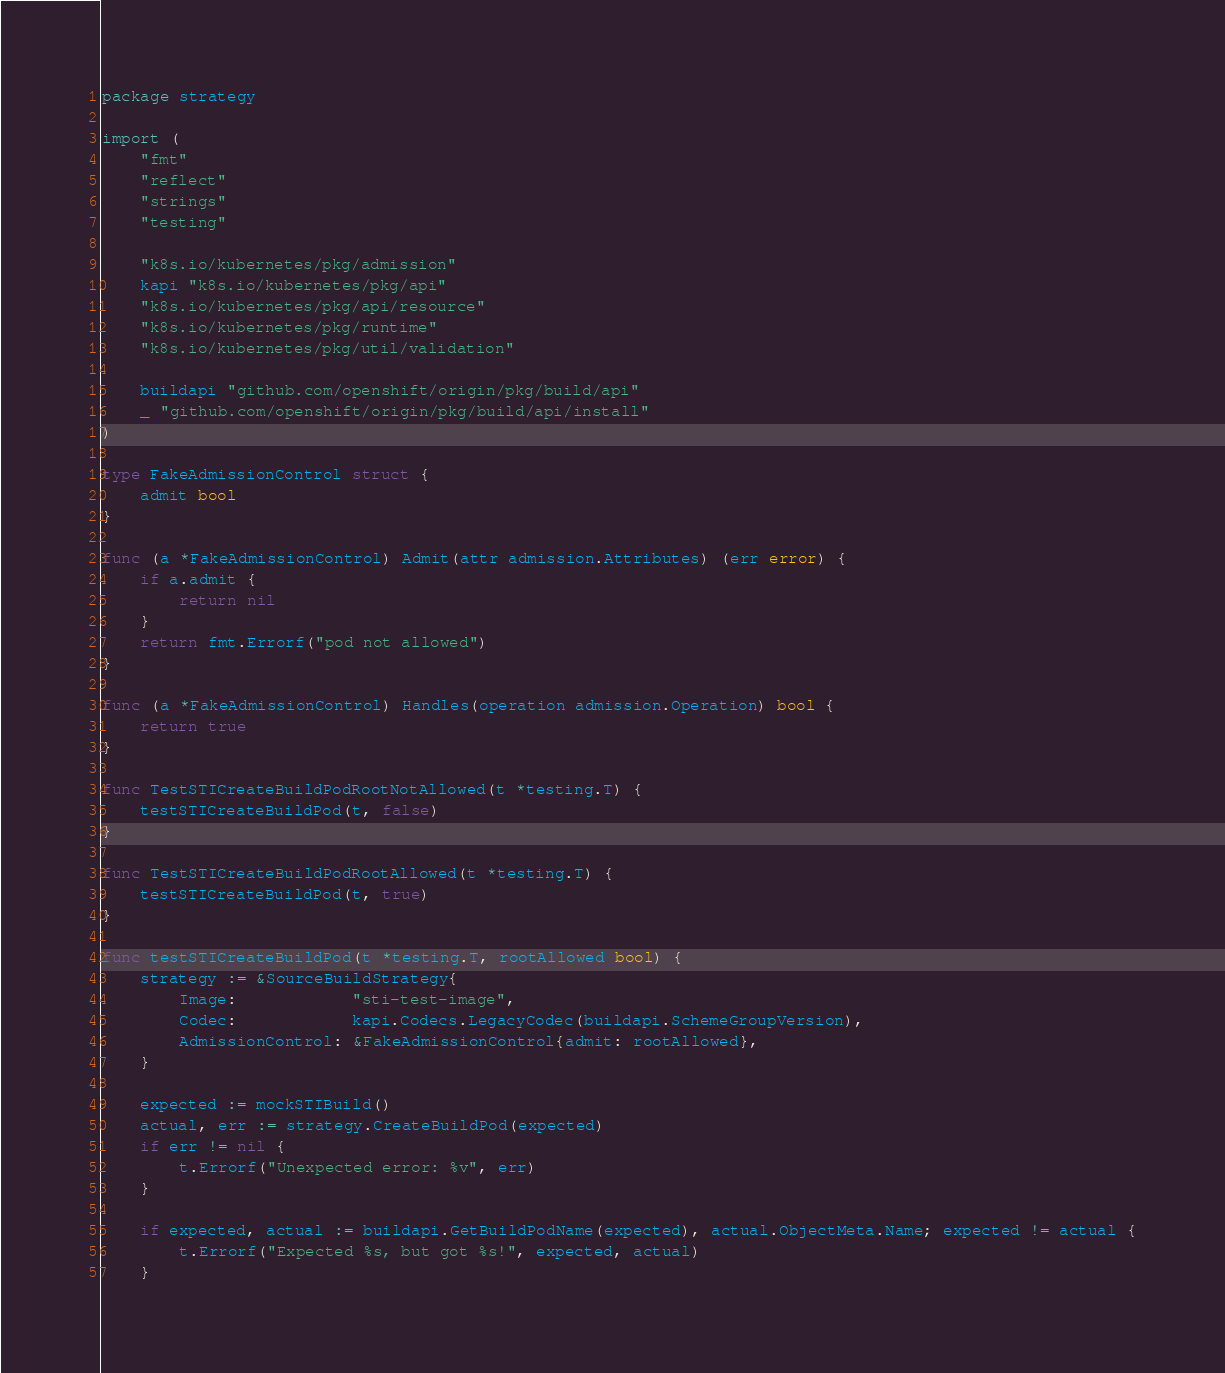Convert code to text. <code><loc_0><loc_0><loc_500><loc_500><_Go_>package strategy

import (
	"fmt"
	"reflect"
	"strings"
	"testing"

	"k8s.io/kubernetes/pkg/admission"
	kapi "k8s.io/kubernetes/pkg/api"
	"k8s.io/kubernetes/pkg/api/resource"
	"k8s.io/kubernetes/pkg/runtime"
	"k8s.io/kubernetes/pkg/util/validation"

	buildapi "github.com/openshift/origin/pkg/build/api"
	_ "github.com/openshift/origin/pkg/build/api/install"
)

type FakeAdmissionControl struct {
	admit bool
}

func (a *FakeAdmissionControl) Admit(attr admission.Attributes) (err error) {
	if a.admit {
		return nil
	}
	return fmt.Errorf("pod not allowed")
}

func (a *FakeAdmissionControl) Handles(operation admission.Operation) bool {
	return true
}

func TestSTICreateBuildPodRootNotAllowed(t *testing.T) {
	testSTICreateBuildPod(t, false)
}

func TestSTICreateBuildPodRootAllowed(t *testing.T) {
	testSTICreateBuildPod(t, true)
}

func testSTICreateBuildPod(t *testing.T, rootAllowed bool) {
	strategy := &SourceBuildStrategy{
		Image:            "sti-test-image",
		Codec:            kapi.Codecs.LegacyCodec(buildapi.SchemeGroupVersion),
		AdmissionControl: &FakeAdmissionControl{admit: rootAllowed},
	}

	expected := mockSTIBuild()
	actual, err := strategy.CreateBuildPod(expected)
	if err != nil {
		t.Errorf("Unexpected error: %v", err)
	}

	if expected, actual := buildapi.GetBuildPodName(expected), actual.ObjectMeta.Name; expected != actual {
		t.Errorf("Expected %s, but got %s!", expected, actual)
	}</code> 